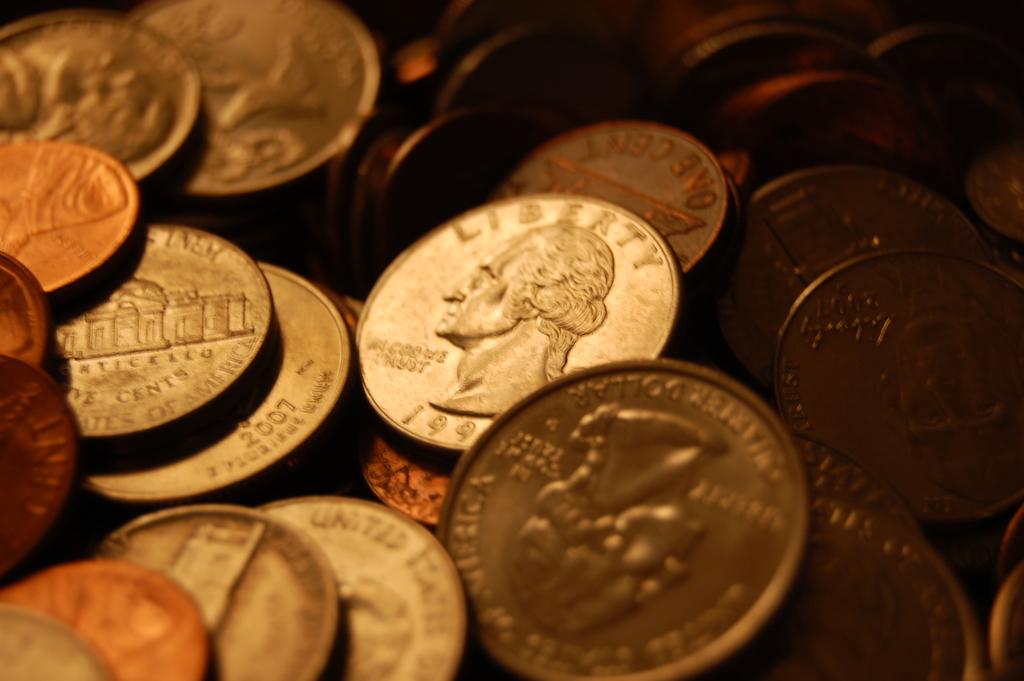What word is on the top of the coin?
Give a very brief answer. Liberty. This is kains?
Offer a very short reply. Unanswerable. 